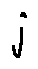Convert formula to latex. <formula><loc_0><loc_0><loc_500><loc_500>j</formula> 